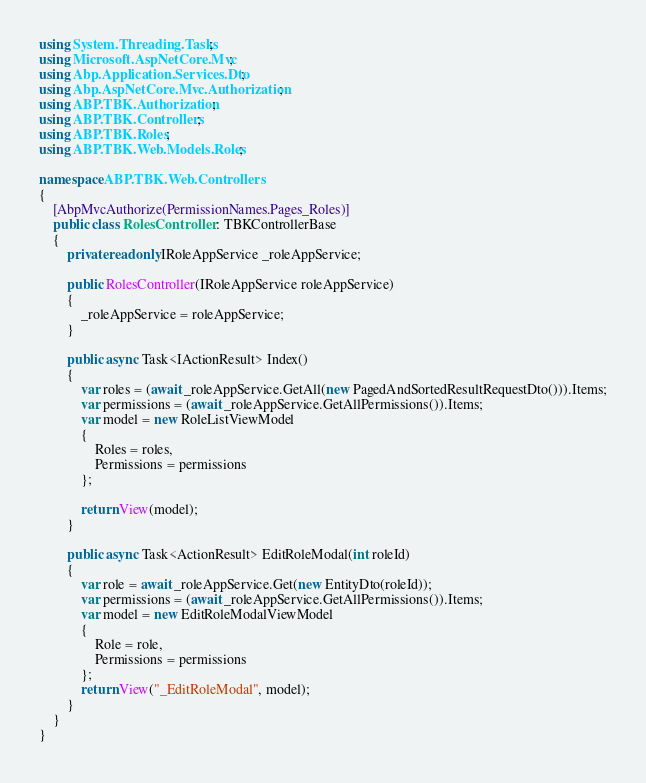<code> <loc_0><loc_0><loc_500><loc_500><_C#_>using System.Threading.Tasks;
using Microsoft.AspNetCore.Mvc;
using Abp.Application.Services.Dto;
using Abp.AspNetCore.Mvc.Authorization;
using ABP.TBK.Authorization;
using ABP.TBK.Controllers;
using ABP.TBK.Roles;
using ABP.TBK.Web.Models.Roles;

namespace ABP.TBK.Web.Controllers
{
    [AbpMvcAuthorize(PermissionNames.Pages_Roles)]
    public class RolesController : TBKControllerBase
    {
        private readonly IRoleAppService _roleAppService;

        public RolesController(IRoleAppService roleAppService)
        {
            _roleAppService = roleAppService;
        }

        public async Task<IActionResult> Index()
        {
            var roles = (await _roleAppService.GetAll(new PagedAndSortedResultRequestDto())).Items;
            var permissions = (await _roleAppService.GetAllPermissions()).Items;
            var model = new RoleListViewModel
            {
                Roles = roles,
                Permissions = permissions
            };

            return View(model);
        }

        public async Task<ActionResult> EditRoleModal(int roleId)
        {
            var role = await _roleAppService.Get(new EntityDto(roleId));
            var permissions = (await _roleAppService.GetAllPermissions()).Items;
            var model = new EditRoleModalViewModel
            {
                Role = role,
                Permissions = permissions
            };
            return View("_EditRoleModal", model);
        }
    }
}
</code> 